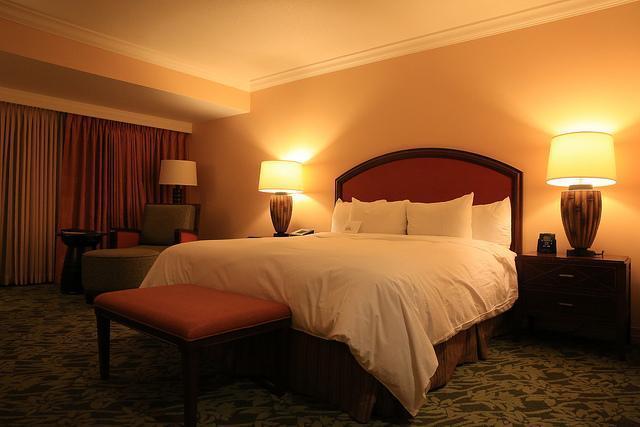How many lamps are on?
Give a very brief answer. 2. How many lampshades are maroon?
Give a very brief answer. 0. How many horse riders?
Give a very brief answer. 0. 